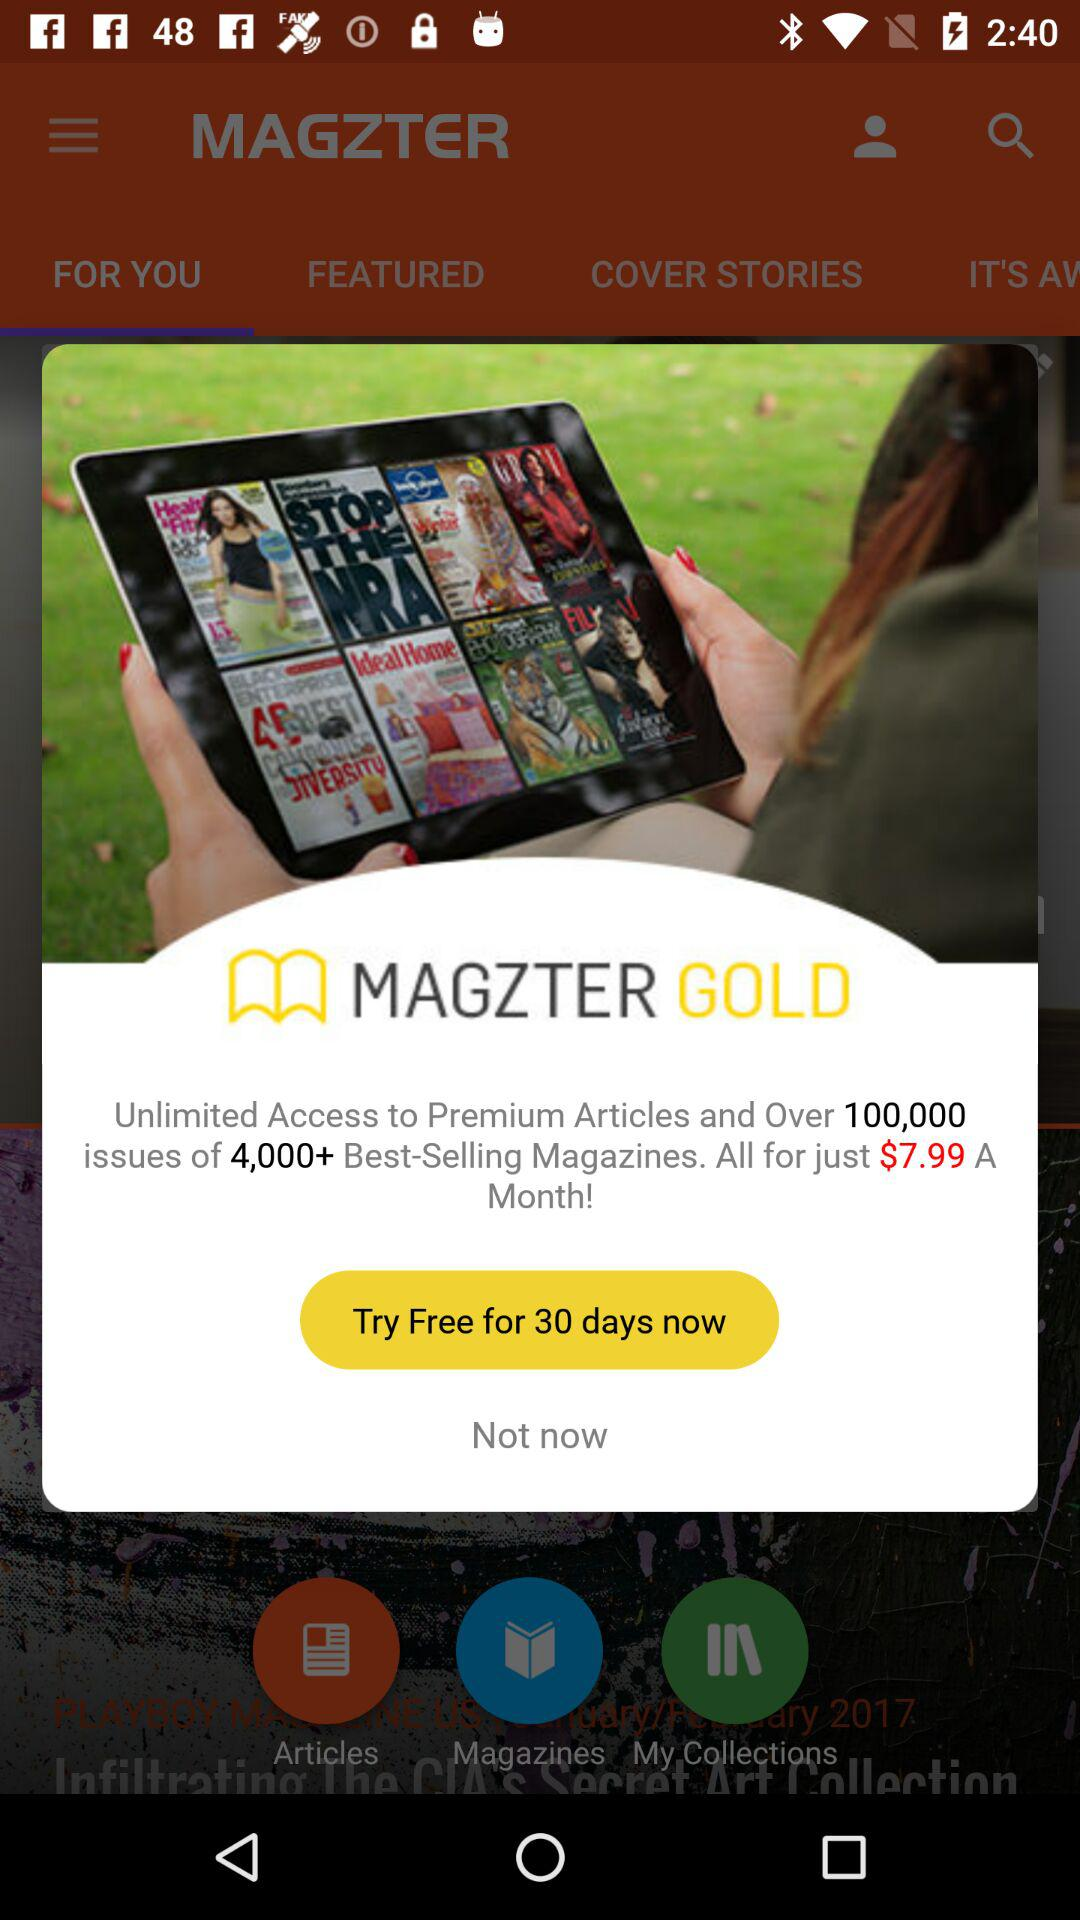For how many days is the trial free? It is free for 30 days. 